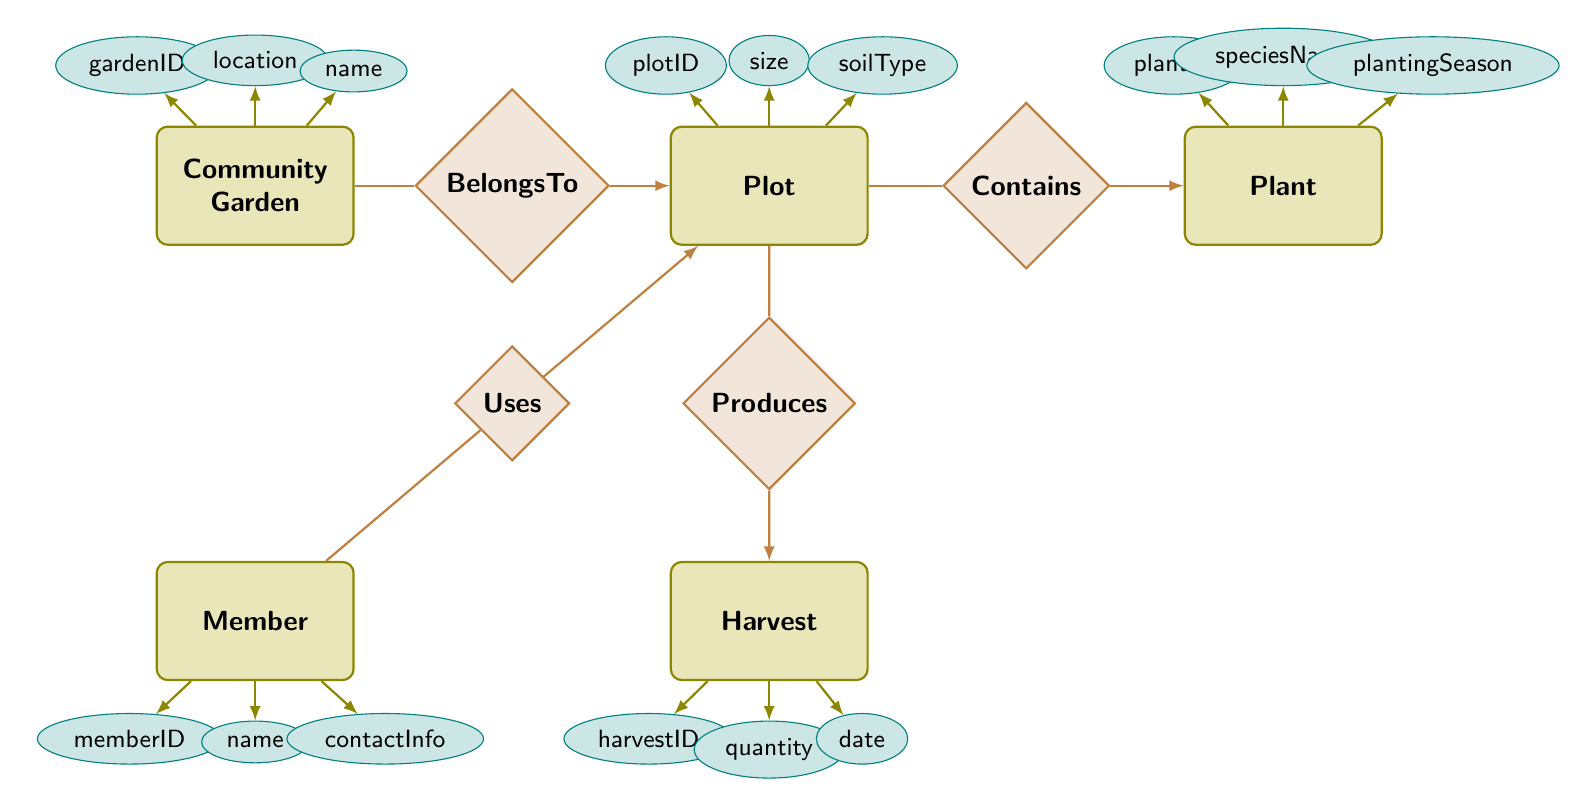What is the name of the relationship between Member and Plot? The relationship is labeled as "Uses" between the "Member" entity and the "Plot" entity in the diagram.
Answer: Uses How many attributes does the Plant entity have? The "Plant" entity has three attributes: plantID, speciesName, and plantingSeason.
Answer: 3 What does the Produces relationship connect? The "Produces" relationship connects the "Plot" and "Harvest" entities, indicating that a specific plot can produce a harvest.
Answer: Plot, Harvest Which entity has the attribute 'quantity'? The attribute 'quantity' is found in the "Harvest" entity, as indicated in the diagram.
Answer: Harvest Which attribute belongs to the CommunityGarden entity? The "CommunityGarden" entity has three attributes: gardenID, location, and name. The term 'location' specifically belongs to this entity.
Answer: location What is the soil type of the Plot entity? The "Plot" entity has an attribute called "soilType"; the specific type is not provided in the diagram, only that this attribute exists.
Answer: soilType How many entities are there in total? There are five entities in the diagram: CommunityGarden, Plot, Member, Plant, and Harvest.
Answer: 5 What relationship connects CommunityGarden to Plot? The relationship labeled "BelongsTo" connects the "CommunityGarden" entity to the "Plot" entity, indicating that any given plot belongs to a particular garden.
Answer: BelongsTo What is the planting season attribute of Plant? The "Plant" entity contains an attribute labeled "plantingSeason," which defines when a specific plant should be planted.
Answer: plantingSeason 